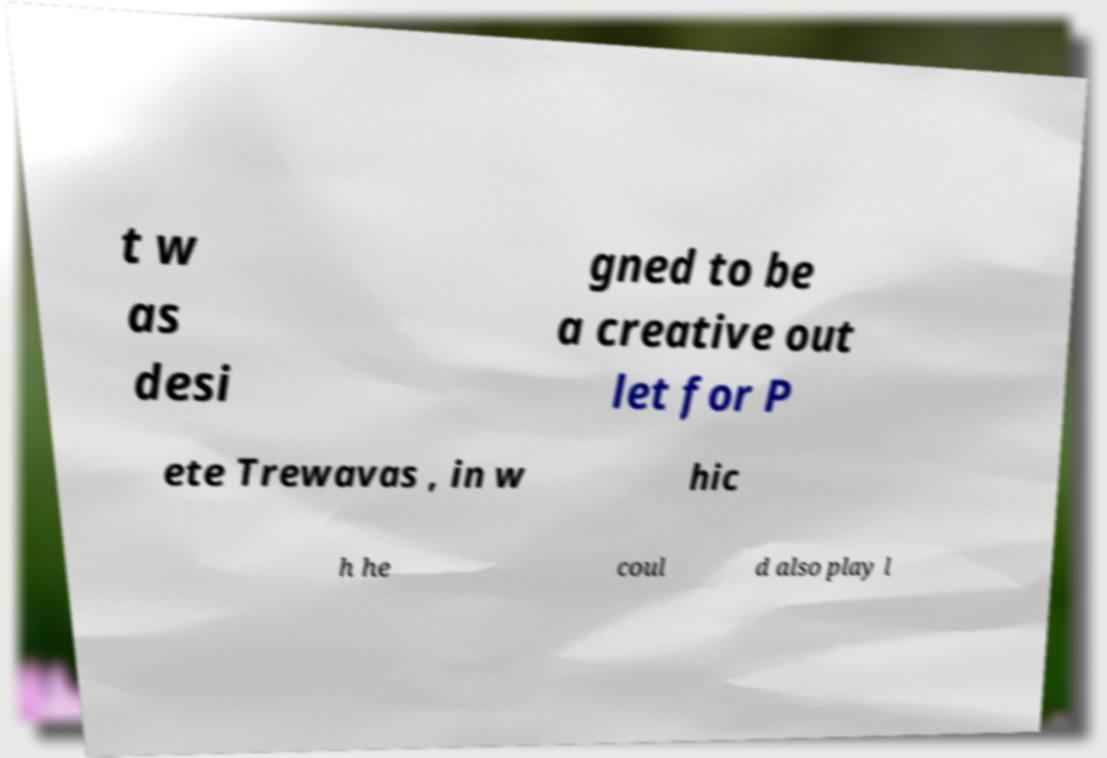I need the written content from this picture converted into text. Can you do that? t w as desi gned to be a creative out let for P ete Trewavas , in w hic h he coul d also play l 